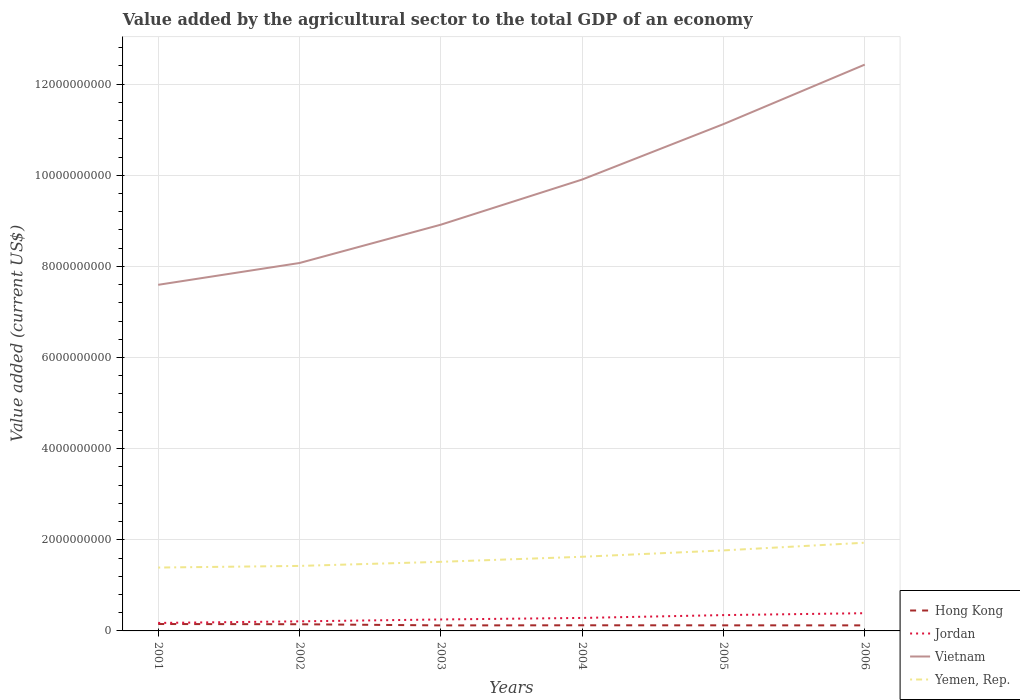Across all years, what is the maximum value added by the agricultural sector to the total GDP in Hong Kong?
Provide a succinct answer. 1.21e+08. In which year was the value added by the agricultural sector to the total GDP in Vietnam maximum?
Offer a terse response. 2001. What is the total value added by the agricultural sector to the total GDP in Vietnam in the graph?
Keep it short and to the point. -3.05e+09. What is the difference between the highest and the second highest value added by the agricultural sector to the total GDP in Yemen, Rep.?
Make the answer very short. 5.45e+08. Are the values on the major ticks of Y-axis written in scientific E-notation?
Give a very brief answer. No. What is the title of the graph?
Your response must be concise. Value added by the agricultural sector to the total GDP of an economy. Does "Puerto Rico" appear as one of the legend labels in the graph?
Ensure brevity in your answer.  No. What is the label or title of the X-axis?
Keep it short and to the point. Years. What is the label or title of the Y-axis?
Your response must be concise. Value added (current US$). What is the Value added (current US$) of Hong Kong in 2001?
Provide a short and direct response. 1.52e+08. What is the Value added (current US$) in Jordan in 2001?
Provide a short and direct response. 1.75e+08. What is the Value added (current US$) in Vietnam in 2001?
Offer a very short reply. 7.60e+09. What is the Value added (current US$) in Yemen, Rep. in 2001?
Ensure brevity in your answer.  1.39e+09. What is the Value added (current US$) of Hong Kong in 2002?
Your answer should be very brief. 1.47e+08. What is the Value added (current US$) of Jordan in 2002?
Offer a very short reply. 2.10e+08. What is the Value added (current US$) in Vietnam in 2002?
Keep it short and to the point. 8.08e+09. What is the Value added (current US$) of Yemen, Rep. in 2002?
Give a very brief answer. 1.43e+09. What is the Value added (current US$) in Hong Kong in 2003?
Make the answer very short. 1.21e+08. What is the Value added (current US$) of Jordan in 2003?
Your response must be concise. 2.52e+08. What is the Value added (current US$) of Vietnam in 2003?
Your answer should be compact. 8.92e+09. What is the Value added (current US$) in Yemen, Rep. in 2003?
Ensure brevity in your answer.  1.52e+09. What is the Value added (current US$) in Hong Kong in 2004?
Your response must be concise. 1.24e+08. What is the Value added (current US$) in Jordan in 2004?
Make the answer very short. 2.85e+08. What is the Value added (current US$) of Vietnam in 2004?
Provide a short and direct response. 9.91e+09. What is the Value added (current US$) in Yemen, Rep. in 2004?
Keep it short and to the point. 1.63e+09. What is the Value added (current US$) in Hong Kong in 2005?
Offer a very short reply. 1.23e+08. What is the Value added (current US$) in Jordan in 2005?
Keep it short and to the point. 3.47e+08. What is the Value added (current US$) in Vietnam in 2005?
Your answer should be very brief. 1.11e+1. What is the Value added (current US$) in Yemen, Rep. in 2005?
Your answer should be very brief. 1.77e+09. What is the Value added (current US$) of Hong Kong in 2006?
Your response must be concise. 1.22e+08. What is the Value added (current US$) of Jordan in 2006?
Make the answer very short. 3.89e+08. What is the Value added (current US$) in Vietnam in 2006?
Your response must be concise. 1.24e+1. What is the Value added (current US$) in Yemen, Rep. in 2006?
Make the answer very short. 1.94e+09. Across all years, what is the maximum Value added (current US$) in Hong Kong?
Your answer should be very brief. 1.52e+08. Across all years, what is the maximum Value added (current US$) in Jordan?
Make the answer very short. 3.89e+08. Across all years, what is the maximum Value added (current US$) of Vietnam?
Make the answer very short. 1.24e+1. Across all years, what is the maximum Value added (current US$) in Yemen, Rep.?
Offer a terse response. 1.94e+09. Across all years, what is the minimum Value added (current US$) of Hong Kong?
Provide a succinct answer. 1.21e+08. Across all years, what is the minimum Value added (current US$) in Jordan?
Your answer should be very brief. 1.75e+08. Across all years, what is the minimum Value added (current US$) in Vietnam?
Provide a short and direct response. 7.60e+09. Across all years, what is the minimum Value added (current US$) in Yemen, Rep.?
Provide a short and direct response. 1.39e+09. What is the total Value added (current US$) in Hong Kong in the graph?
Give a very brief answer. 7.88e+08. What is the total Value added (current US$) of Jordan in the graph?
Provide a succinct answer. 1.66e+09. What is the total Value added (current US$) of Vietnam in the graph?
Provide a short and direct response. 5.80e+1. What is the total Value added (current US$) in Yemen, Rep. in the graph?
Offer a terse response. 9.67e+09. What is the difference between the Value added (current US$) of Hong Kong in 2001 and that in 2002?
Your response must be concise. 5.00e+06. What is the difference between the Value added (current US$) of Jordan in 2001 and that in 2002?
Offer a very short reply. -3.47e+07. What is the difference between the Value added (current US$) of Vietnam in 2001 and that in 2002?
Make the answer very short. -4.79e+08. What is the difference between the Value added (current US$) of Yemen, Rep. in 2001 and that in 2002?
Keep it short and to the point. -3.58e+07. What is the difference between the Value added (current US$) of Hong Kong in 2001 and that in 2003?
Your answer should be very brief. 3.02e+07. What is the difference between the Value added (current US$) of Jordan in 2001 and that in 2003?
Provide a succinct answer. -7.62e+07. What is the difference between the Value added (current US$) in Vietnam in 2001 and that in 2003?
Your answer should be very brief. -1.32e+09. What is the difference between the Value added (current US$) in Yemen, Rep. in 2001 and that in 2003?
Your answer should be very brief. -1.26e+08. What is the difference between the Value added (current US$) in Hong Kong in 2001 and that in 2004?
Provide a succinct answer. 2.79e+07. What is the difference between the Value added (current US$) in Jordan in 2001 and that in 2004?
Offer a very short reply. -1.10e+08. What is the difference between the Value added (current US$) in Vietnam in 2001 and that in 2004?
Make the answer very short. -2.31e+09. What is the difference between the Value added (current US$) of Yemen, Rep. in 2001 and that in 2004?
Provide a short and direct response. -2.36e+08. What is the difference between the Value added (current US$) in Hong Kong in 2001 and that in 2005?
Your answer should be compact. 2.90e+07. What is the difference between the Value added (current US$) of Jordan in 2001 and that in 2005?
Give a very brief answer. -1.72e+08. What is the difference between the Value added (current US$) in Vietnam in 2001 and that in 2005?
Offer a terse response. -3.53e+09. What is the difference between the Value added (current US$) of Yemen, Rep. in 2001 and that in 2005?
Ensure brevity in your answer.  -3.76e+08. What is the difference between the Value added (current US$) of Hong Kong in 2001 and that in 2006?
Offer a very short reply. 2.96e+07. What is the difference between the Value added (current US$) of Jordan in 2001 and that in 2006?
Ensure brevity in your answer.  -2.14e+08. What is the difference between the Value added (current US$) of Vietnam in 2001 and that in 2006?
Your response must be concise. -4.83e+09. What is the difference between the Value added (current US$) of Yemen, Rep. in 2001 and that in 2006?
Offer a very short reply. -5.45e+08. What is the difference between the Value added (current US$) in Hong Kong in 2002 and that in 2003?
Your response must be concise. 2.52e+07. What is the difference between the Value added (current US$) in Jordan in 2002 and that in 2003?
Your answer should be compact. -4.15e+07. What is the difference between the Value added (current US$) of Vietnam in 2002 and that in 2003?
Keep it short and to the point. -8.41e+08. What is the difference between the Value added (current US$) of Yemen, Rep. in 2002 and that in 2003?
Ensure brevity in your answer.  -8.99e+07. What is the difference between the Value added (current US$) of Hong Kong in 2002 and that in 2004?
Give a very brief answer. 2.29e+07. What is the difference between the Value added (current US$) of Jordan in 2002 and that in 2004?
Give a very brief answer. -7.50e+07. What is the difference between the Value added (current US$) in Vietnam in 2002 and that in 2004?
Offer a very short reply. -1.83e+09. What is the difference between the Value added (current US$) in Yemen, Rep. in 2002 and that in 2004?
Ensure brevity in your answer.  -2.01e+08. What is the difference between the Value added (current US$) of Hong Kong in 2002 and that in 2005?
Your response must be concise. 2.40e+07. What is the difference between the Value added (current US$) in Jordan in 2002 and that in 2005?
Give a very brief answer. -1.37e+08. What is the difference between the Value added (current US$) in Vietnam in 2002 and that in 2005?
Give a very brief answer. -3.05e+09. What is the difference between the Value added (current US$) in Yemen, Rep. in 2002 and that in 2005?
Your response must be concise. -3.40e+08. What is the difference between the Value added (current US$) of Hong Kong in 2002 and that in 2006?
Give a very brief answer. 2.46e+07. What is the difference between the Value added (current US$) of Jordan in 2002 and that in 2006?
Your answer should be very brief. -1.79e+08. What is the difference between the Value added (current US$) of Vietnam in 2002 and that in 2006?
Provide a succinct answer. -4.35e+09. What is the difference between the Value added (current US$) in Yemen, Rep. in 2002 and that in 2006?
Your answer should be compact. -5.10e+08. What is the difference between the Value added (current US$) in Hong Kong in 2003 and that in 2004?
Offer a very short reply. -2.29e+06. What is the difference between the Value added (current US$) in Jordan in 2003 and that in 2004?
Provide a short and direct response. -3.35e+07. What is the difference between the Value added (current US$) of Vietnam in 2003 and that in 2004?
Provide a succinct answer. -9.91e+08. What is the difference between the Value added (current US$) in Yemen, Rep. in 2003 and that in 2004?
Provide a succinct answer. -1.11e+08. What is the difference between the Value added (current US$) in Hong Kong in 2003 and that in 2005?
Offer a very short reply. -1.18e+06. What is the difference between the Value added (current US$) in Jordan in 2003 and that in 2005?
Give a very brief answer. -9.57e+07. What is the difference between the Value added (current US$) in Vietnam in 2003 and that in 2005?
Ensure brevity in your answer.  -2.21e+09. What is the difference between the Value added (current US$) of Yemen, Rep. in 2003 and that in 2005?
Provide a short and direct response. -2.51e+08. What is the difference between the Value added (current US$) of Hong Kong in 2003 and that in 2006?
Offer a very short reply. -5.54e+05. What is the difference between the Value added (current US$) of Jordan in 2003 and that in 2006?
Provide a succinct answer. -1.38e+08. What is the difference between the Value added (current US$) in Vietnam in 2003 and that in 2006?
Provide a succinct answer. -3.51e+09. What is the difference between the Value added (current US$) of Yemen, Rep. in 2003 and that in 2006?
Offer a very short reply. -4.20e+08. What is the difference between the Value added (current US$) of Hong Kong in 2004 and that in 2005?
Offer a very short reply. 1.12e+06. What is the difference between the Value added (current US$) of Jordan in 2004 and that in 2005?
Your answer should be compact. -6.22e+07. What is the difference between the Value added (current US$) of Vietnam in 2004 and that in 2005?
Give a very brief answer. -1.22e+09. What is the difference between the Value added (current US$) of Yemen, Rep. in 2004 and that in 2005?
Provide a succinct answer. -1.40e+08. What is the difference between the Value added (current US$) in Hong Kong in 2004 and that in 2006?
Provide a short and direct response. 1.74e+06. What is the difference between the Value added (current US$) of Jordan in 2004 and that in 2006?
Offer a very short reply. -1.04e+08. What is the difference between the Value added (current US$) in Vietnam in 2004 and that in 2006?
Provide a succinct answer. -2.52e+09. What is the difference between the Value added (current US$) in Yemen, Rep. in 2004 and that in 2006?
Your answer should be very brief. -3.09e+08. What is the difference between the Value added (current US$) in Hong Kong in 2005 and that in 2006?
Your answer should be very brief. 6.23e+05. What is the difference between the Value added (current US$) in Jordan in 2005 and that in 2006?
Ensure brevity in your answer.  -4.18e+07. What is the difference between the Value added (current US$) in Vietnam in 2005 and that in 2006?
Provide a succinct answer. -1.31e+09. What is the difference between the Value added (current US$) of Yemen, Rep. in 2005 and that in 2006?
Provide a short and direct response. -1.69e+08. What is the difference between the Value added (current US$) in Hong Kong in 2001 and the Value added (current US$) in Jordan in 2002?
Offer a very short reply. -5.85e+07. What is the difference between the Value added (current US$) in Hong Kong in 2001 and the Value added (current US$) in Vietnam in 2002?
Keep it short and to the point. -7.92e+09. What is the difference between the Value added (current US$) in Hong Kong in 2001 and the Value added (current US$) in Yemen, Rep. in 2002?
Your answer should be very brief. -1.28e+09. What is the difference between the Value added (current US$) in Jordan in 2001 and the Value added (current US$) in Vietnam in 2002?
Give a very brief answer. -7.90e+09. What is the difference between the Value added (current US$) of Jordan in 2001 and the Value added (current US$) of Yemen, Rep. in 2002?
Offer a very short reply. -1.25e+09. What is the difference between the Value added (current US$) of Vietnam in 2001 and the Value added (current US$) of Yemen, Rep. in 2002?
Offer a terse response. 6.17e+09. What is the difference between the Value added (current US$) of Hong Kong in 2001 and the Value added (current US$) of Jordan in 2003?
Your answer should be very brief. -1.00e+08. What is the difference between the Value added (current US$) of Hong Kong in 2001 and the Value added (current US$) of Vietnam in 2003?
Your answer should be compact. -8.76e+09. What is the difference between the Value added (current US$) in Hong Kong in 2001 and the Value added (current US$) in Yemen, Rep. in 2003?
Your answer should be compact. -1.37e+09. What is the difference between the Value added (current US$) in Jordan in 2001 and the Value added (current US$) in Vietnam in 2003?
Make the answer very short. -8.74e+09. What is the difference between the Value added (current US$) in Jordan in 2001 and the Value added (current US$) in Yemen, Rep. in 2003?
Your response must be concise. -1.34e+09. What is the difference between the Value added (current US$) in Vietnam in 2001 and the Value added (current US$) in Yemen, Rep. in 2003?
Your answer should be very brief. 6.08e+09. What is the difference between the Value added (current US$) in Hong Kong in 2001 and the Value added (current US$) in Jordan in 2004?
Offer a terse response. -1.33e+08. What is the difference between the Value added (current US$) in Hong Kong in 2001 and the Value added (current US$) in Vietnam in 2004?
Your answer should be very brief. -9.76e+09. What is the difference between the Value added (current US$) of Hong Kong in 2001 and the Value added (current US$) of Yemen, Rep. in 2004?
Offer a terse response. -1.48e+09. What is the difference between the Value added (current US$) of Jordan in 2001 and the Value added (current US$) of Vietnam in 2004?
Give a very brief answer. -9.73e+09. What is the difference between the Value added (current US$) of Jordan in 2001 and the Value added (current US$) of Yemen, Rep. in 2004?
Offer a very short reply. -1.45e+09. What is the difference between the Value added (current US$) in Vietnam in 2001 and the Value added (current US$) in Yemen, Rep. in 2004?
Provide a short and direct response. 5.97e+09. What is the difference between the Value added (current US$) in Hong Kong in 2001 and the Value added (current US$) in Jordan in 2005?
Offer a very short reply. -1.96e+08. What is the difference between the Value added (current US$) of Hong Kong in 2001 and the Value added (current US$) of Vietnam in 2005?
Keep it short and to the point. -1.10e+1. What is the difference between the Value added (current US$) of Hong Kong in 2001 and the Value added (current US$) of Yemen, Rep. in 2005?
Ensure brevity in your answer.  -1.62e+09. What is the difference between the Value added (current US$) in Jordan in 2001 and the Value added (current US$) in Vietnam in 2005?
Provide a short and direct response. -1.09e+1. What is the difference between the Value added (current US$) of Jordan in 2001 and the Value added (current US$) of Yemen, Rep. in 2005?
Your response must be concise. -1.59e+09. What is the difference between the Value added (current US$) of Vietnam in 2001 and the Value added (current US$) of Yemen, Rep. in 2005?
Provide a succinct answer. 5.83e+09. What is the difference between the Value added (current US$) of Hong Kong in 2001 and the Value added (current US$) of Jordan in 2006?
Provide a short and direct response. -2.37e+08. What is the difference between the Value added (current US$) of Hong Kong in 2001 and the Value added (current US$) of Vietnam in 2006?
Your answer should be very brief. -1.23e+1. What is the difference between the Value added (current US$) in Hong Kong in 2001 and the Value added (current US$) in Yemen, Rep. in 2006?
Provide a succinct answer. -1.78e+09. What is the difference between the Value added (current US$) of Jordan in 2001 and the Value added (current US$) of Vietnam in 2006?
Give a very brief answer. -1.23e+1. What is the difference between the Value added (current US$) in Jordan in 2001 and the Value added (current US$) in Yemen, Rep. in 2006?
Make the answer very short. -1.76e+09. What is the difference between the Value added (current US$) in Vietnam in 2001 and the Value added (current US$) in Yemen, Rep. in 2006?
Provide a succinct answer. 5.66e+09. What is the difference between the Value added (current US$) of Hong Kong in 2002 and the Value added (current US$) of Jordan in 2003?
Your response must be concise. -1.05e+08. What is the difference between the Value added (current US$) in Hong Kong in 2002 and the Value added (current US$) in Vietnam in 2003?
Keep it short and to the point. -8.77e+09. What is the difference between the Value added (current US$) of Hong Kong in 2002 and the Value added (current US$) of Yemen, Rep. in 2003?
Offer a very short reply. -1.37e+09. What is the difference between the Value added (current US$) of Jordan in 2002 and the Value added (current US$) of Vietnam in 2003?
Your answer should be compact. -8.71e+09. What is the difference between the Value added (current US$) in Jordan in 2002 and the Value added (current US$) in Yemen, Rep. in 2003?
Your answer should be compact. -1.31e+09. What is the difference between the Value added (current US$) of Vietnam in 2002 and the Value added (current US$) of Yemen, Rep. in 2003?
Your answer should be compact. 6.56e+09. What is the difference between the Value added (current US$) in Hong Kong in 2002 and the Value added (current US$) in Jordan in 2004?
Ensure brevity in your answer.  -1.38e+08. What is the difference between the Value added (current US$) in Hong Kong in 2002 and the Value added (current US$) in Vietnam in 2004?
Provide a short and direct response. -9.76e+09. What is the difference between the Value added (current US$) of Hong Kong in 2002 and the Value added (current US$) of Yemen, Rep. in 2004?
Provide a succinct answer. -1.48e+09. What is the difference between the Value added (current US$) in Jordan in 2002 and the Value added (current US$) in Vietnam in 2004?
Offer a terse response. -9.70e+09. What is the difference between the Value added (current US$) of Jordan in 2002 and the Value added (current US$) of Yemen, Rep. in 2004?
Give a very brief answer. -1.42e+09. What is the difference between the Value added (current US$) in Vietnam in 2002 and the Value added (current US$) in Yemen, Rep. in 2004?
Keep it short and to the point. 6.45e+09. What is the difference between the Value added (current US$) of Hong Kong in 2002 and the Value added (current US$) of Jordan in 2005?
Your response must be concise. -2.01e+08. What is the difference between the Value added (current US$) in Hong Kong in 2002 and the Value added (current US$) in Vietnam in 2005?
Your answer should be compact. -1.10e+1. What is the difference between the Value added (current US$) in Hong Kong in 2002 and the Value added (current US$) in Yemen, Rep. in 2005?
Your answer should be compact. -1.62e+09. What is the difference between the Value added (current US$) of Jordan in 2002 and the Value added (current US$) of Vietnam in 2005?
Your response must be concise. -1.09e+1. What is the difference between the Value added (current US$) of Jordan in 2002 and the Value added (current US$) of Yemen, Rep. in 2005?
Provide a succinct answer. -1.56e+09. What is the difference between the Value added (current US$) of Vietnam in 2002 and the Value added (current US$) of Yemen, Rep. in 2005?
Offer a terse response. 6.31e+09. What is the difference between the Value added (current US$) of Hong Kong in 2002 and the Value added (current US$) of Jordan in 2006?
Give a very brief answer. -2.42e+08. What is the difference between the Value added (current US$) of Hong Kong in 2002 and the Value added (current US$) of Vietnam in 2006?
Keep it short and to the point. -1.23e+1. What is the difference between the Value added (current US$) of Hong Kong in 2002 and the Value added (current US$) of Yemen, Rep. in 2006?
Your answer should be compact. -1.79e+09. What is the difference between the Value added (current US$) of Jordan in 2002 and the Value added (current US$) of Vietnam in 2006?
Provide a succinct answer. -1.22e+1. What is the difference between the Value added (current US$) of Jordan in 2002 and the Value added (current US$) of Yemen, Rep. in 2006?
Offer a terse response. -1.73e+09. What is the difference between the Value added (current US$) of Vietnam in 2002 and the Value added (current US$) of Yemen, Rep. in 2006?
Provide a short and direct response. 6.14e+09. What is the difference between the Value added (current US$) of Hong Kong in 2003 and the Value added (current US$) of Jordan in 2004?
Provide a succinct answer. -1.64e+08. What is the difference between the Value added (current US$) of Hong Kong in 2003 and the Value added (current US$) of Vietnam in 2004?
Keep it short and to the point. -9.79e+09. What is the difference between the Value added (current US$) in Hong Kong in 2003 and the Value added (current US$) in Yemen, Rep. in 2004?
Ensure brevity in your answer.  -1.51e+09. What is the difference between the Value added (current US$) of Jordan in 2003 and the Value added (current US$) of Vietnam in 2004?
Make the answer very short. -9.66e+09. What is the difference between the Value added (current US$) of Jordan in 2003 and the Value added (current US$) of Yemen, Rep. in 2004?
Your answer should be compact. -1.38e+09. What is the difference between the Value added (current US$) in Vietnam in 2003 and the Value added (current US$) in Yemen, Rep. in 2004?
Offer a terse response. 7.29e+09. What is the difference between the Value added (current US$) of Hong Kong in 2003 and the Value added (current US$) of Jordan in 2005?
Give a very brief answer. -2.26e+08. What is the difference between the Value added (current US$) in Hong Kong in 2003 and the Value added (current US$) in Vietnam in 2005?
Offer a very short reply. -1.10e+1. What is the difference between the Value added (current US$) in Hong Kong in 2003 and the Value added (current US$) in Yemen, Rep. in 2005?
Offer a terse response. -1.65e+09. What is the difference between the Value added (current US$) of Jordan in 2003 and the Value added (current US$) of Vietnam in 2005?
Offer a very short reply. -1.09e+1. What is the difference between the Value added (current US$) of Jordan in 2003 and the Value added (current US$) of Yemen, Rep. in 2005?
Make the answer very short. -1.52e+09. What is the difference between the Value added (current US$) in Vietnam in 2003 and the Value added (current US$) in Yemen, Rep. in 2005?
Give a very brief answer. 7.15e+09. What is the difference between the Value added (current US$) of Hong Kong in 2003 and the Value added (current US$) of Jordan in 2006?
Keep it short and to the point. -2.68e+08. What is the difference between the Value added (current US$) of Hong Kong in 2003 and the Value added (current US$) of Vietnam in 2006?
Offer a very short reply. -1.23e+1. What is the difference between the Value added (current US$) in Hong Kong in 2003 and the Value added (current US$) in Yemen, Rep. in 2006?
Offer a very short reply. -1.81e+09. What is the difference between the Value added (current US$) of Jordan in 2003 and the Value added (current US$) of Vietnam in 2006?
Your answer should be compact. -1.22e+1. What is the difference between the Value added (current US$) of Jordan in 2003 and the Value added (current US$) of Yemen, Rep. in 2006?
Your response must be concise. -1.68e+09. What is the difference between the Value added (current US$) in Vietnam in 2003 and the Value added (current US$) in Yemen, Rep. in 2006?
Provide a succinct answer. 6.98e+09. What is the difference between the Value added (current US$) of Hong Kong in 2004 and the Value added (current US$) of Jordan in 2005?
Your answer should be very brief. -2.24e+08. What is the difference between the Value added (current US$) of Hong Kong in 2004 and the Value added (current US$) of Vietnam in 2005?
Make the answer very short. -1.10e+1. What is the difference between the Value added (current US$) in Hong Kong in 2004 and the Value added (current US$) in Yemen, Rep. in 2005?
Give a very brief answer. -1.64e+09. What is the difference between the Value added (current US$) of Jordan in 2004 and the Value added (current US$) of Vietnam in 2005?
Offer a terse response. -1.08e+1. What is the difference between the Value added (current US$) of Jordan in 2004 and the Value added (current US$) of Yemen, Rep. in 2005?
Make the answer very short. -1.48e+09. What is the difference between the Value added (current US$) of Vietnam in 2004 and the Value added (current US$) of Yemen, Rep. in 2005?
Your answer should be very brief. 8.14e+09. What is the difference between the Value added (current US$) of Hong Kong in 2004 and the Value added (current US$) of Jordan in 2006?
Your response must be concise. -2.65e+08. What is the difference between the Value added (current US$) of Hong Kong in 2004 and the Value added (current US$) of Vietnam in 2006?
Your answer should be compact. -1.23e+1. What is the difference between the Value added (current US$) of Hong Kong in 2004 and the Value added (current US$) of Yemen, Rep. in 2006?
Offer a terse response. -1.81e+09. What is the difference between the Value added (current US$) in Jordan in 2004 and the Value added (current US$) in Vietnam in 2006?
Provide a short and direct response. -1.21e+1. What is the difference between the Value added (current US$) of Jordan in 2004 and the Value added (current US$) of Yemen, Rep. in 2006?
Your answer should be compact. -1.65e+09. What is the difference between the Value added (current US$) in Vietnam in 2004 and the Value added (current US$) in Yemen, Rep. in 2006?
Your answer should be compact. 7.97e+09. What is the difference between the Value added (current US$) of Hong Kong in 2005 and the Value added (current US$) of Jordan in 2006?
Your response must be concise. -2.67e+08. What is the difference between the Value added (current US$) in Hong Kong in 2005 and the Value added (current US$) in Vietnam in 2006?
Provide a short and direct response. -1.23e+1. What is the difference between the Value added (current US$) of Hong Kong in 2005 and the Value added (current US$) of Yemen, Rep. in 2006?
Your answer should be very brief. -1.81e+09. What is the difference between the Value added (current US$) in Jordan in 2005 and the Value added (current US$) in Vietnam in 2006?
Your answer should be compact. -1.21e+1. What is the difference between the Value added (current US$) in Jordan in 2005 and the Value added (current US$) in Yemen, Rep. in 2006?
Ensure brevity in your answer.  -1.59e+09. What is the difference between the Value added (current US$) of Vietnam in 2005 and the Value added (current US$) of Yemen, Rep. in 2006?
Keep it short and to the point. 9.19e+09. What is the average Value added (current US$) in Hong Kong per year?
Keep it short and to the point. 1.31e+08. What is the average Value added (current US$) of Jordan per year?
Offer a terse response. 2.76e+08. What is the average Value added (current US$) in Vietnam per year?
Keep it short and to the point. 9.67e+09. What is the average Value added (current US$) in Yemen, Rep. per year?
Provide a short and direct response. 1.61e+09. In the year 2001, what is the difference between the Value added (current US$) of Hong Kong and Value added (current US$) of Jordan?
Offer a terse response. -2.38e+07. In the year 2001, what is the difference between the Value added (current US$) in Hong Kong and Value added (current US$) in Vietnam?
Ensure brevity in your answer.  -7.44e+09. In the year 2001, what is the difference between the Value added (current US$) in Hong Kong and Value added (current US$) in Yemen, Rep.?
Keep it short and to the point. -1.24e+09. In the year 2001, what is the difference between the Value added (current US$) in Jordan and Value added (current US$) in Vietnam?
Ensure brevity in your answer.  -7.42e+09. In the year 2001, what is the difference between the Value added (current US$) of Jordan and Value added (current US$) of Yemen, Rep.?
Give a very brief answer. -1.22e+09. In the year 2001, what is the difference between the Value added (current US$) in Vietnam and Value added (current US$) in Yemen, Rep.?
Offer a terse response. 6.21e+09. In the year 2002, what is the difference between the Value added (current US$) in Hong Kong and Value added (current US$) in Jordan?
Your answer should be compact. -6.35e+07. In the year 2002, what is the difference between the Value added (current US$) in Hong Kong and Value added (current US$) in Vietnam?
Your answer should be very brief. -7.93e+09. In the year 2002, what is the difference between the Value added (current US$) in Hong Kong and Value added (current US$) in Yemen, Rep.?
Keep it short and to the point. -1.28e+09. In the year 2002, what is the difference between the Value added (current US$) of Jordan and Value added (current US$) of Vietnam?
Your response must be concise. -7.87e+09. In the year 2002, what is the difference between the Value added (current US$) of Jordan and Value added (current US$) of Yemen, Rep.?
Ensure brevity in your answer.  -1.22e+09. In the year 2002, what is the difference between the Value added (current US$) of Vietnam and Value added (current US$) of Yemen, Rep.?
Your response must be concise. 6.65e+09. In the year 2003, what is the difference between the Value added (current US$) in Hong Kong and Value added (current US$) in Jordan?
Ensure brevity in your answer.  -1.30e+08. In the year 2003, what is the difference between the Value added (current US$) in Hong Kong and Value added (current US$) in Vietnam?
Provide a succinct answer. -8.79e+09. In the year 2003, what is the difference between the Value added (current US$) in Hong Kong and Value added (current US$) in Yemen, Rep.?
Offer a very short reply. -1.40e+09. In the year 2003, what is the difference between the Value added (current US$) of Jordan and Value added (current US$) of Vietnam?
Provide a short and direct response. -8.66e+09. In the year 2003, what is the difference between the Value added (current US$) of Jordan and Value added (current US$) of Yemen, Rep.?
Your answer should be compact. -1.27e+09. In the year 2003, what is the difference between the Value added (current US$) of Vietnam and Value added (current US$) of Yemen, Rep.?
Keep it short and to the point. 7.40e+09. In the year 2004, what is the difference between the Value added (current US$) of Hong Kong and Value added (current US$) of Jordan?
Ensure brevity in your answer.  -1.61e+08. In the year 2004, what is the difference between the Value added (current US$) in Hong Kong and Value added (current US$) in Vietnam?
Ensure brevity in your answer.  -9.78e+09. In the year 2004, what is the difference between the Value added (current US$) in Hong Kong and Value added (current US$) in Yemen, Rep.?
Your answer should be compact. -1.50e+09. In the year 2004, what is the difference between the Value added (current US$) in Jordan and Value added (current US$) in Vietnam?
Ensure brevity in your answer.  -9.62e+09. In the year 2004, what is the difference between the Value added (current US$) in Jordan and Value added (current US$) in Yemen, Rep.?
Ensure brevity in your answer.  -1.34e+09. In the year 2004, what is the difference between the Value added (current US$) in Vietnam and Value added (current US$) in Yemen, Rep.?
Your answer should be very brief. 8.28e+09. In the year 2005, what is the difference between the Value added (current US$) of Hong Kong and Value added (current US$) of Jordan?
Provide a succinct answer. -2.25e+08. In the year 2005, what is the difference between the Value added (current US$) of Hong Kong and Value added (current US$) of Vietnam?
Keep it short and to the point. -1.10e+1. In the year 2005, what is the difference between the Value added (current US$) in Hong Kong and Value added (current US$) in Yemen, Rep.?
Keep it short and to the point. -1.64e+09. In the year 2005, what is the difference between the Value added (current US$) in Jordan and Value added (current US$) in Vietnam?
Make the answer very short. -1.08e+1. In the year 2005, what is the difference between the Value added (current US$) of Jordan and Value added (current US$) of Yemen, Rep.?
Make the answer very short. -1.42e+09. In the year 2005, what is the difference between the Value added (current US$) of Vietnam and Value added (current US$) of Yemen, Rep.?
Your response must be concise. 9.36e+09. In the year 2006, what is the difference between the Value added (current US$) in Hong Kong and Value added (current US$) in Jordan?
Give a very brief answer. -2.67e+08. In the year 2006, what is the difference between the Value added (current US$) of Hong Kong and Value added (current US$) of Vietnam?
Keep it short and to the point. -1.23e+1. In the year 2006, what is the difference between the Value added (current US$) in Hong Kong and Value added (current US$) in Yemen, Rep.?
Your answer should be very brief. -1.81e+09. In the year 2006, what is the difference between the Value added (current US$) of Jordan and Value added (current US$) of Vietnam?
Offer a terse response. -1.20e+1. In the year 2006, what is the difference between the Value added (current US$) in Jordan and Value added (current US$) in Yemen, Rep.?
Provide a short and direct response. -1.55e+09. In the year 2006, what is the difference between the Value added (current US$) of Vietnam and Value added (current US$) of Yemen, Rep.?
Your answer should be very brief. 1.05e+1. What is the ratio of the Value added (current US$) in Hong Kong in 2001 to that in 2002?
Make the answer very short. 1.03. What is the ratio of the Value added (current US$) in Jordan in 2001 to that in 2002?
Provide a succinct answer. 0.83. What is the ratio of the Value added (current US$) in Vietnam in 2001 to that in 2002?
Give a very brief answer. 0.94. What is the ratio of the Value added (current US$) of Yemen, Rep. in 2001 to that in 2002?
Your answer should be very brief. 0.97. What is the ratio of the Value added (current US$) in Hong Kong in 2001 to that in 2003?
Your response must be concise. 1.25. What is the ratio of the Value added (current US$) of Jordan in 2001 to that in 2003?
Keep it short and to the point. 0.7. What is the ratio of the Value added (current US$) in Vietnam in 2001 to that in 2003?
Your response must be concise. 0.85. What is the ratio of the Value added (current US$) in Yemen, Rep. in 2001 to that in 2003?
Offer a terse response. 0.92. What is the ratio of the Value added (current US$) of Hong Kong in 2001 to that in 2004?
Make the answer very short. 1.23. What is the ratio of the Value added (current US$) of Jordan in 2001 to that in 2004?
Your answer should be compact. 0.62. What is the ratio of the Value added (current US$) in Vietnam in 2001 to that in 2004?
Your answer should be very brief. 0.77. What is the ratio of the Value added (current US$) in Yemen, Rep. in 2001 to that in 2004?
Make the answer very short. 0.85. What is the ratio of the Value added (current US$) in Hong Kong in 2001 to that in 2005?
Your answer should be very brief. 1.24. What is the ratio of the Value added (current US$) of Jordan in 2001 to that in 2005?
Your response must be concise. 0.51. What is the ratio of the Value added (current US$) in Vietnam in 2001 to that in 2005?
Your answer should be very brief. 0.68. What is the ratio of the Value added (current US$) in Yemen, Rep. in 2001 to that in 2005?
Your answer should be very brief. 0.79. What is the ratio of the Value added (current US$) of Hong Kong in 2001 to that in 2006?
Keep it short and to the point. 1.24. What is the ratio of the Value added (current US$) of Jordan in 2001 to that in 2006?
Provide a succinct answer. 0.45. What is the ratio of the Value added (current US$) in Vietnam in 2001 to that in 2006?
Offer a terse response. 0.61. What is the ratio of the Value added (current US$) in Yemen, Rep. in 2001 to that in 2006?
Your response must be concise. 0.72. What is the ratio of the Value added (current US$) in Hong Kong in 2002 to that in 2003?
Keep it short and to the point. 1.21. What is the ratio of the Value added (current US$) of Jordan in 2002 to that in 2003?
Provide a short and direct response. 0.84. What is the ratio of the Value added (current US$) of Vietnam in 2002 to that in 2003?
Keep it short and to the point. 0.91. What is the ratio of the Value added (current US$) in Yemen, Rep. in 2002 to that in 2003?
Offer a terse response. 0.94. What is the ratio of the Value added (current US$) in Hong Kong in 2002 to that in 2004?
Your response must be concise. 1.19. What is the ratio of the Value added (current US$) of Jordan in 2002 to that in 2004?
Keep it short and to the point. 0.74. What is the ratio of the Value added (current US$) of Vietnam in 2002 to that in 2004?
Offer a very short reply. 0.82. What is the ratio of the Value added (current US$) in Yemen, Rep. in 2002 to that in 2004?
Offer a terse response. 0.88. What is the ratio of the Value added (current US$) in Hong Kong in 2002 to that in 2005?
Your answer should be compact. 1.2. What is the ratio of the Value added (current US$) of Jordan in 2002 to that in 2005?
Provide a succinct answer. 0.6. What is the ratio of the Value added (current US$) in Vietnam in 2002 to that in 2005?
Provide a short and direct response. 0.73. What is the ratio of the Value added (current US$) of Yemen, Rep. in 2002 to that in 2005?
Provide a short and direct response. 0.81. What is the ratio of the Value added (current US$) in Hong Kong in 2002 to that in 2006?
Your answer should be very brief. 1.2. What is the ratio of the Value added (current US$) of Jordan in 2002 to that in 2006?
Offer a very short reply. 0.54. What is the ratio of the Value added (current US$) of Vietnam in 2002 to that in 2006?
Offer a very short reply. 0.65. What is the ratio of the Value added (current US$) in Yemen, Rep. in 2002 to that in 2006?
Give a very brief answer. 0.74. What is the ratio of the Value added (current US$) of Hong Kong in 2003 to that in 2004?
Give a very brief answer. 0.98. What is the ratio of the Value added (current US$) in Jordan in 2003 to that in 2004?
Keep it short and to the point. 0.88. What is the ratio of the Value added (current US$) in Vietnam in 2003 to that in 2004?
Keep it short and to the point. 0.9. What is the ratio of the Value added (current US$) of Yemen, Rep. in 2003 to that in 2004?
Offer a terse response. 0.93. What is the ratio of the Value added (current US$) of Jordan in 2003 to that in 2005?
Keep it short and to the point. 0.72. What is the ratio of the Value added (current US$) of Vietnam in 2003 to that in 2005?
Keep it short and to the point. 0.8. What is the ratio of the Value added (current US$) in Yemen, Rep. in 2003 to that in 2005?
Offer a very short reply. 0.86. What is the ratio of the Value added (current US$) in Jordan in 2003 to that in 2006?
Your response must be concise. 0.65. What is the ratio of the Value added (current US$) in Vietnam in 2003 to that in 2006?
Offer a terse response. 0.72. What is the ratio of the Value added (current US$) of Yemen, Rep. in 2003 to that in 2006?
Your response must be concise. 0.78. What is the ratio of the Value added (current US$) of Hong Kong in 2004 to that in 2005?
Your response must be concise. 1.01. What is the ratio of the Value added (current US$) of Jordan in 2004 to that in 2005?
Offer a terse response. 0.82. What is the ratio of the Value added (current US$) of Vietnam in 2004 to that in 2005?
Provide a succinct answer. 0.89. What is the ratio of the Value added (current US$) of Yemen, Rep. in 2004 to that in 2005?
Your response must be concise. 0.92. What is the ratio of the Value added (current US$) in Hong Kong in 2004 to that in 2006?
Offer a very short reply. 1.01. What is the ratio of the Value added (current US$) of Jordan in 2004 to that in 2006?
Ensure brevity in your answer.  0.73. What is the ratio of the Value added (current US$) of Vietnam in 2004 to that in 2006?
Offer a very short reply. 0.8. What is the ratio of the Value added (current US$) in Yemen, Rep. in 2004 to that in 2006?
Provide a short and direct response. 0.84. What is the ratio of the Value added (current US$) in Hong Kong in 2005 to that in 2006?
Keep it short and to the point. 1.01. What is the ratio of the Value added (current US$) in Jordan in 2005 to that in 2006?
Provide a short and direct response. 0.89. What is the ratio of the Value added (current US$) in Vietnam in 2005 to that in 2006?
Your answer should be compact. 0.89. What is the ratio of the Value added (current US$) of Yemen, Rep. in 2005 to that in 2006?
Your answer should be very brief. 0.91. What is the difference between the highest and the second highest Value added (current US$) of Hong Kong?
Your answer should be compact. 5.00e+06. What is the difference between the highest and the second highest Value added (current US$) in Jordan?
Offer a terse response. 4.18e+07. What is the difference between the highest and the second highest Value added (current US$) of Vietnam?
Give a very brief answer. 1.31e+09. What is the difference between the highest and the second highest Value added (current US$) of Yemen, Rep.?
Offer a very short reply. 1.69e+08. What is the difference between the highest and the lowest Value added (current US$) in Hong Kong?
Provide a short and direct response. 3.02e+07. What is the difference between the highest and the lowest Value added (current US$) of Jordan?
Offer a very short reply. 2.14e+08. What is the difference between the highest and the lowest Value added (current US$) of Vietnam?
Make the answer very short. 4.83e+09. What is the difference between the highest and the lowest Value added (current US$) of Yemen, Rep.?
Your response must be concise. 5.45e+08. 